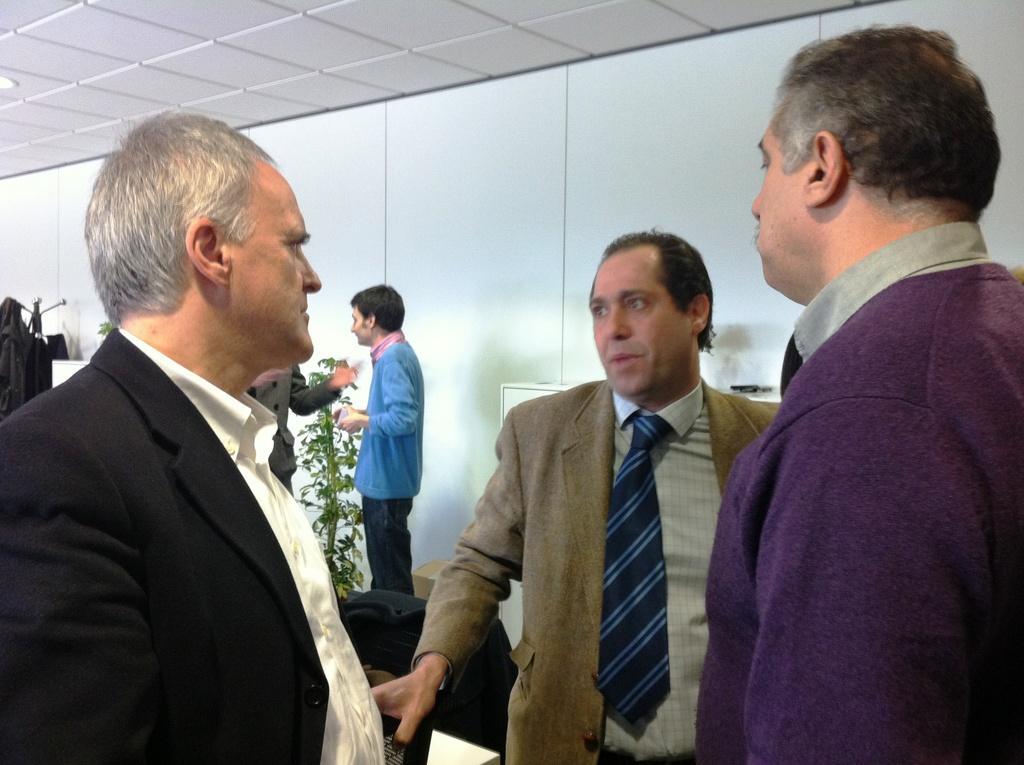Describe this image in one or two sentences. In this image there are a few people standing and there is a chair, table, a plant and there is a hoodie hanging on the rack. In the background there is a wall. At the top of the image there is a ceiling. 